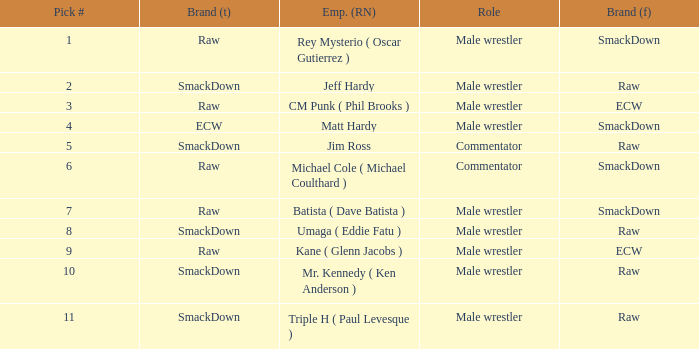What role did Pick # 10 have? Male wrestler. 